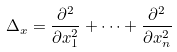Convert formula to latex. <formula><loc_0><loc_0><loc_500><loc_500>\Delta _ { x } = \frac { \partial ^ { 2 } } { \partial x _ { 1 } ^ { 2 } } + \dots + \frac { \partial ^ { 2 } } { \partial x _ { n } ^ { 2 } }</formula> 